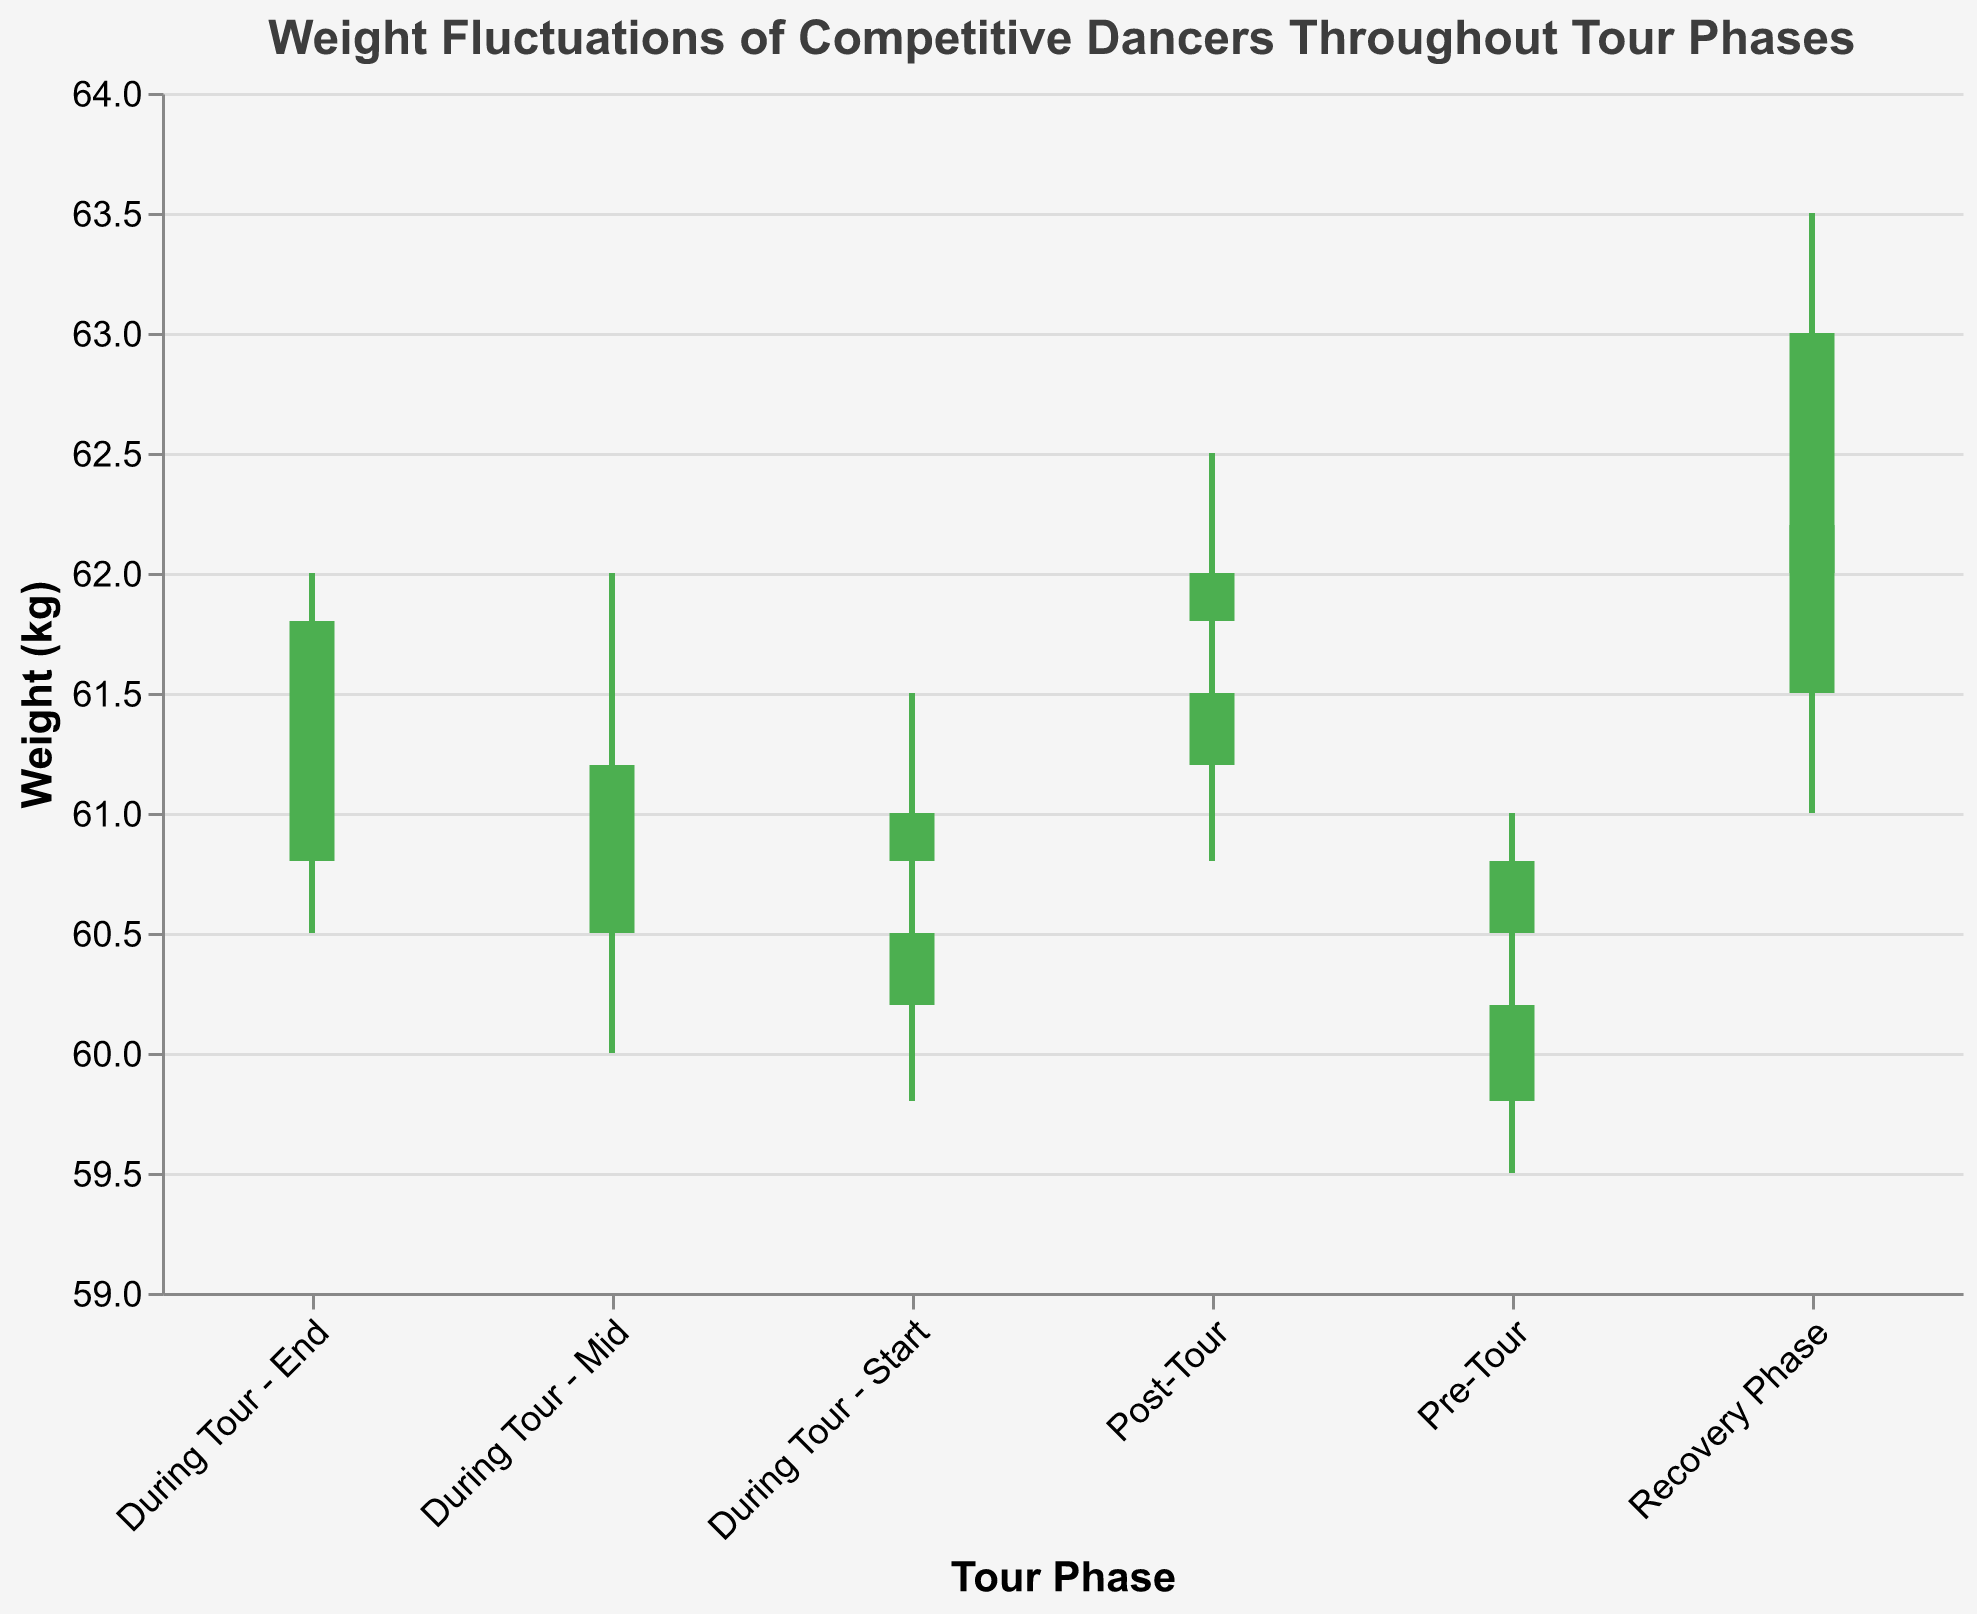What are the tour phases shown in the figure? The X-axis labels indicate the different tour phases represented in the candlestick plot.
Answer: Pre-Tour, During Tour - Start, During Tour - Mid, During Tour - End, Post-Tour, Recovery Phase Which phase shows the highest closing weight? The highest closing weight can be identified by looking at the top of the candlestick for each phase. The Recovery Phase has the highest closing weight of 63.0 kg.
Answer: Recovery Phase What is the difference between the highest high and the lowest low during the Pre-Tour phase? The Pre-Tour phase has two data points: the highest high is 61.0 and the lowest low is 59.5. The difference is 61.0 - 59.5 = 1.5 kg.
Answer: 1.5 During the "During Tour - Mid" phase, how much did the closing weight change on average? Average the closing weights of the two data points for the "During Tour - Mid" phase. The closing weights are 61.2 and 61.0. (61.2 + 61.0) / 2 = 61.1 kg.
Answer: 61.1 In which phase is the range between the high and the low the smallest? The range can be calculated for each phase by subtracting the low from the high and comparing the results. The smallest range is 0.7 kg during "During Tour - Start" (61.0 - 60.3).
Answer: During Tour - Start How many times did the weight decrease from open to close during the "During Tour - Start" phase? Compare the open and close values for the "During Tour - Start" phase data points. The weight decreased once from 60.2 to 60.5, but not from 60.8 to 61.0.
Answer: 1 Which phase shows the largest difference in opening weights? The largest difference in opening weights can be determined by comparing the opening values within each phase. The Recovery Phase shows the largest difference (62.5 - 61.5 = 1.0 kg).
Answer: Recovery Phase What color are the candlesticks representing weight increase from open to close? The candlesticks where the closing weight is higher than the opening weight are green.
Answer: Green Are there any phases with consistent weight increase from open to close in all data points? Check each phase to see if all candlesticks are green. No phase has consistent weight increase in all data points.
Answer: No 